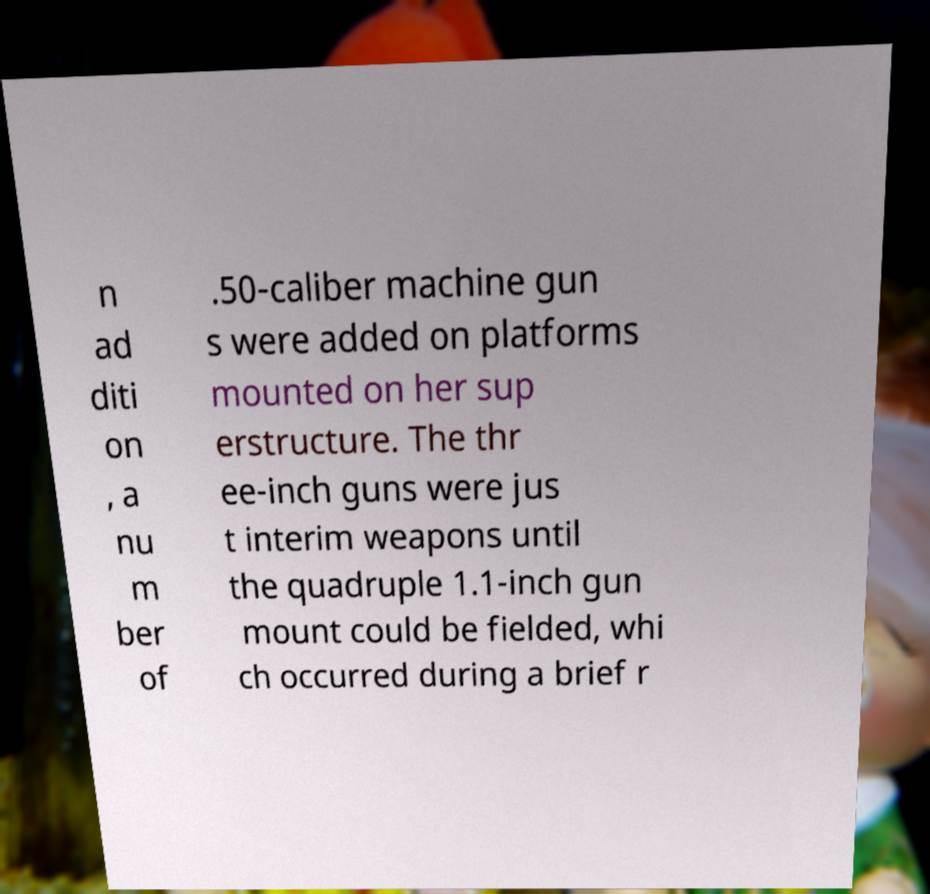For documentation purposes, I need the text within this image transcribed. Could you provide that? n ad diti on , a nu m ber of .50-caliber machine gun s were added on platforms mounted on her sup erstructure. The thr ee-inch guns were jus t interim weapons until the quadruple 1.1-inch gun mount could be fielded, whi ch occurred during a brief r 